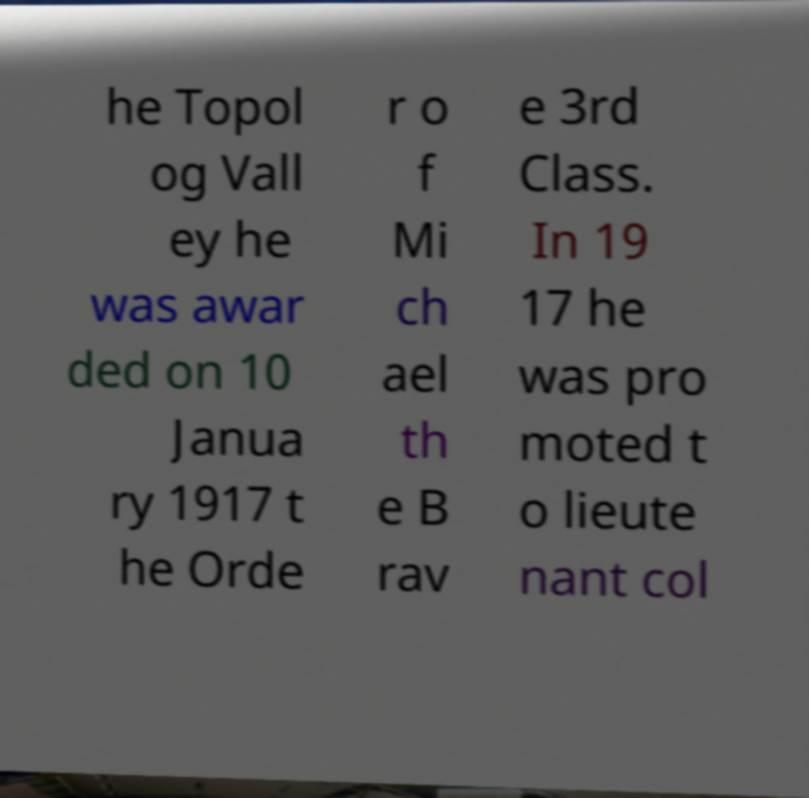Can you read and provide the text displayed in the image?This photo seems to have some interesting text. Can you extract and type it out for me? he Topol og Vall ey he was awar ded on 10 Janua ry 1917 t he Orde r o f Mi ch ael th e B rav e 3rd Class. In 19 17 he was pro moted t o lieute nant col 